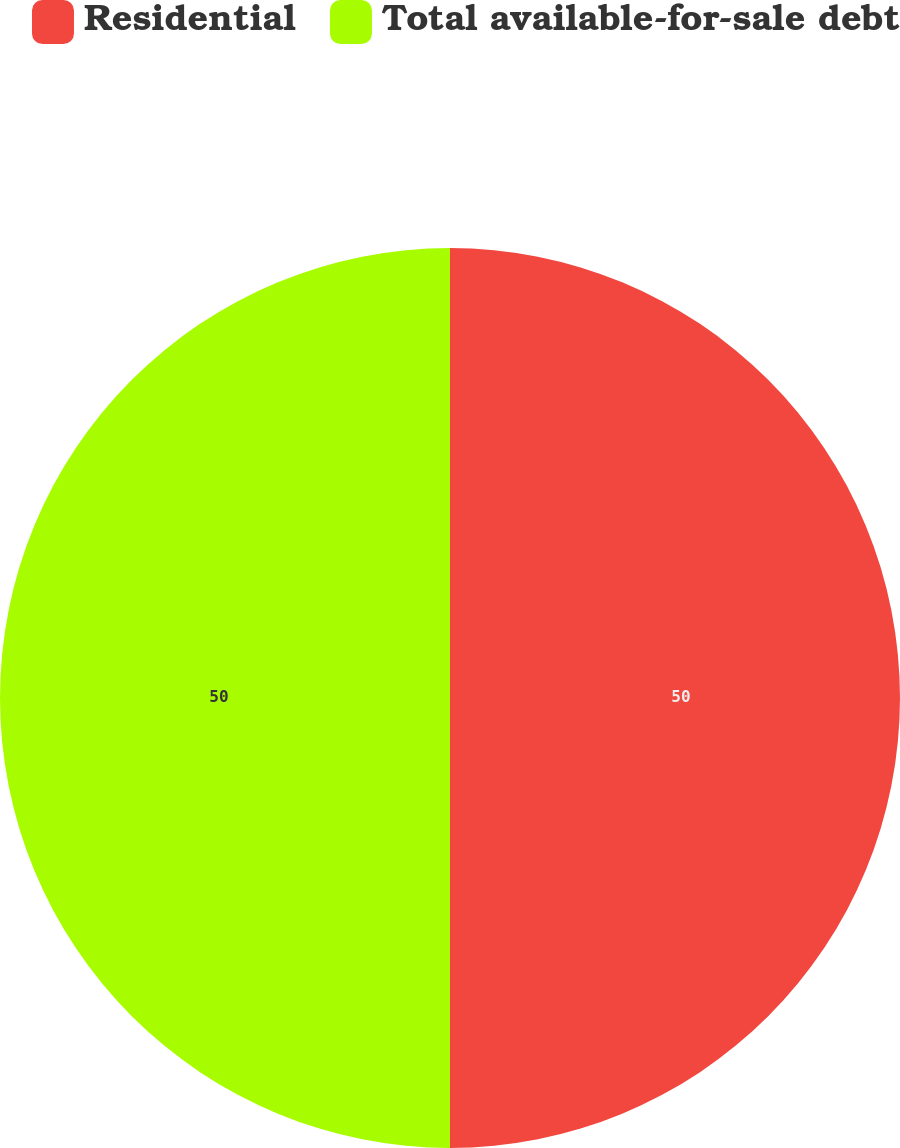Convert chart to OTSL. <chart><loc_0><loc_0><loc_500><loc_500><pie_chart><fcel>Residential<fcel>Total available-for-sale debt<nl><fcel>50.0%<fcel>50.0%<nl></chart> 